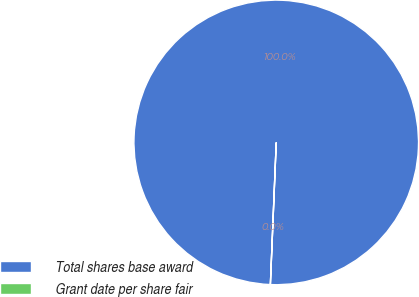<chart> <loc_0><loc_0><loc_500><loc_500><pie_chart><fcel>Total shares base award<fcel>Grant date per share fair<nl><fcel>100.0%<fcel>0.0%<nl></chart> 